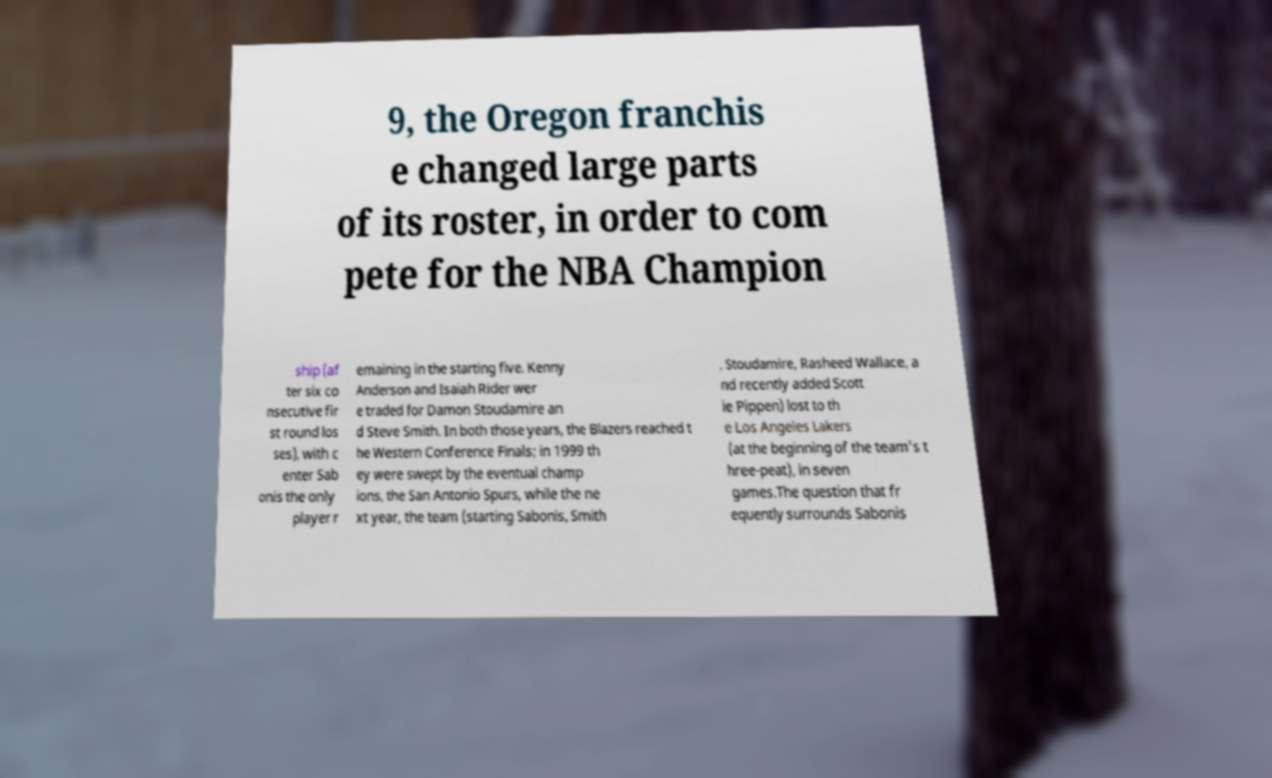What messages or text are displayed in this image? I need them in a readable, typed format. 9, the Oregon franchis e changed large parts of its roster, in order to com pete for the NBA Champion ship (af ter six co nsecutive fir st round los ses), with c enter Sab onis the only player r emaining in the starting five. Kenny Anderson and Isaiah Rider wer e traded for Damon Stoudamire an d Steve Smith. In both those years, the Blazers reached t he Western Conference Finals; in 1999 th ey were swept by the eventual champ ions, the San Antonio Spurs, while the ne xt year, the team (starting Sabonis, Smith , Stoudamire, Rasheed Wallace, a nd recently added Scott ie Pippen) lost to th e Los Angeles Lakers (at the beginning of the team's t hree-peat), in seven games.The question that fr equently surrounds Sabonis 